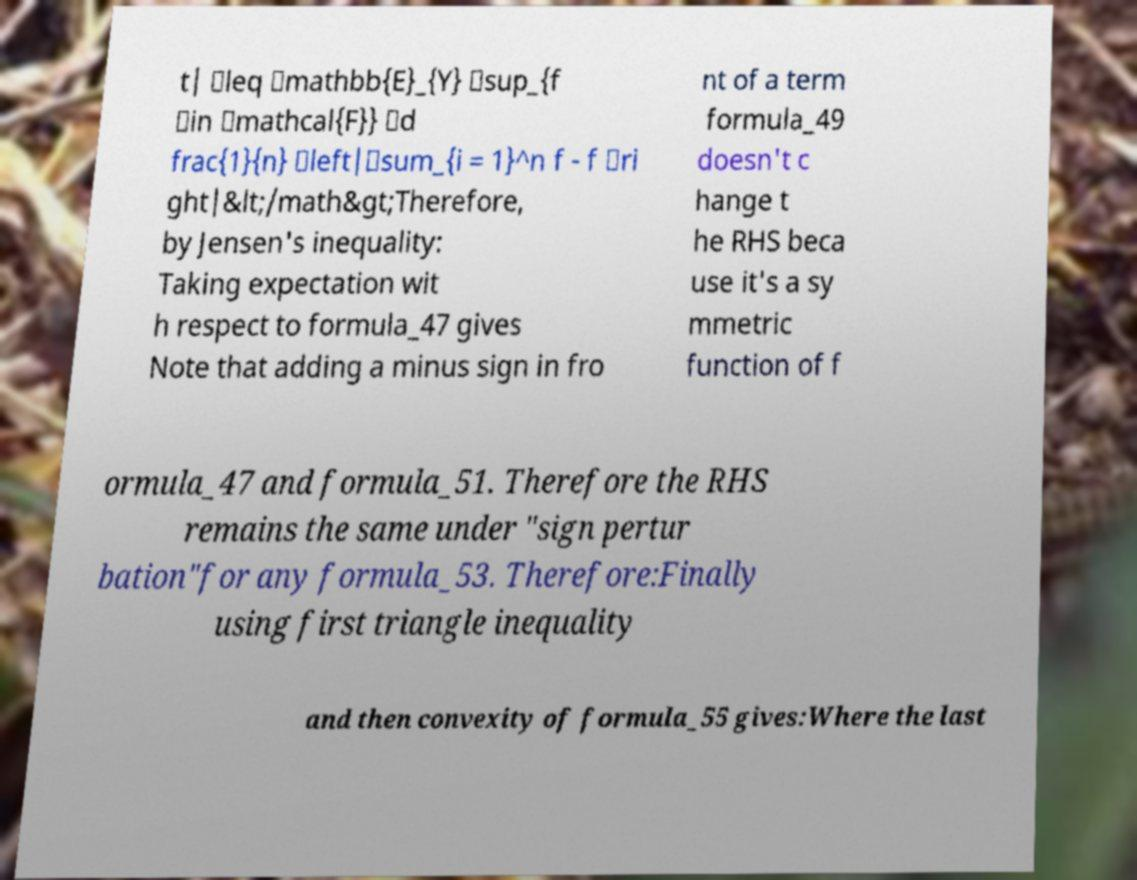I need the written content from this picture converted into text. Can you do that? t| \leq \mathbb{E}_{Y} \sup_{f \in \mathcal{F}} \d frac{1}{n} \left|\sum_{i = 1}^n f - f \ri ght|&lt;/math&gt;Therefore, by Jensen's inequality: Taking expectation wit h respect to formula_47 gives Note that adding a minus sign in fro nt of a term formula_49 doesn't c hange t he RHS beca use it's a sy mmetric function of f ormula_47 and formula_51. Therefore the RHS remains the same under "sign pertur bation"for any formula_53. Therefore:Finally using first triangle inequality and then convexity of formula_55 gives:Where the last 